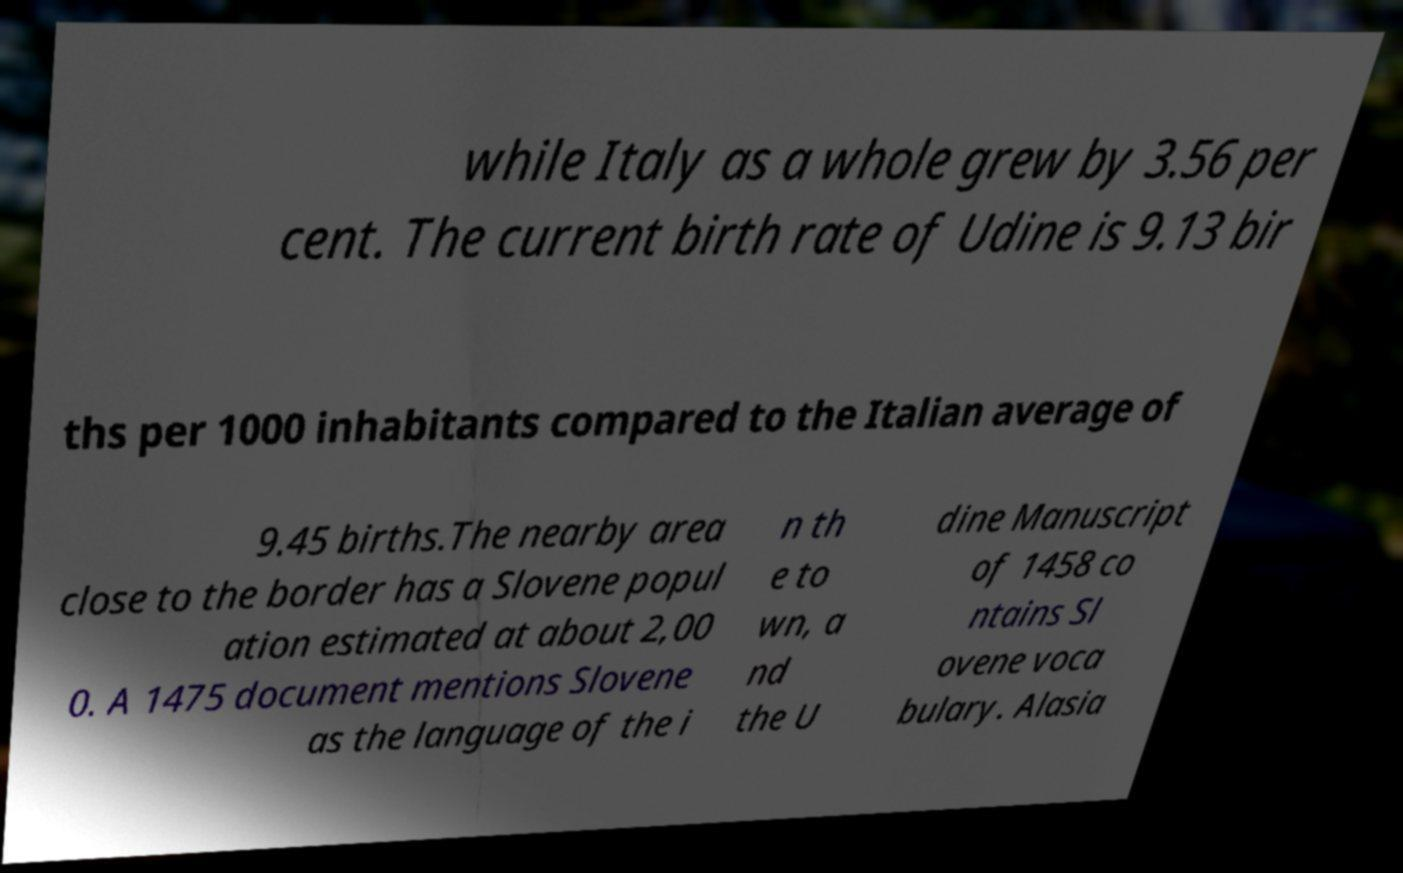Please read and relay the text visible in this image. What does it say? while Italy as a whole grew by 3.56 per cent. The current birth rate of Udine is 9.13 bir ths per 1000 inhabitants compared to the Italian average of 9.45 births.The nearby area close to the border has a Slovene popul ation estimated at about 2,00 0. A 1475 document mentions Slovene as the language of the i n th e to wn, a nd the U dine Manuscript of 1458 co ntains Sl ovene voca bulary. Alasia 